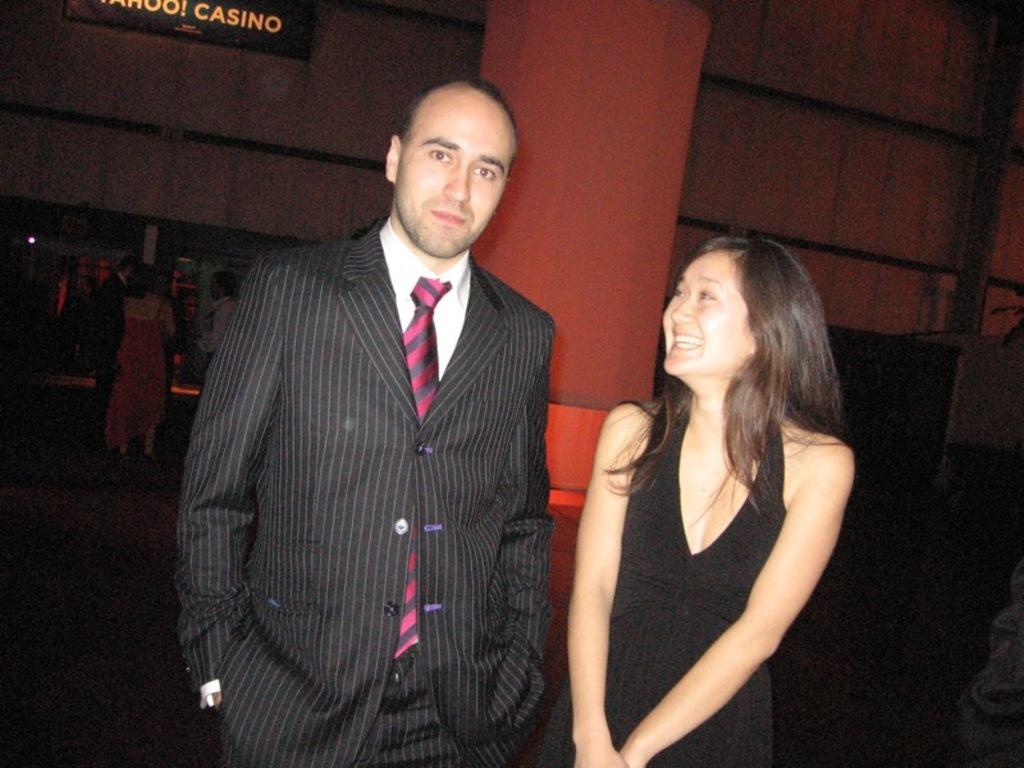Please provide a concise description of this image. In this image I can see two persons visible in front of beam , backside there is the wall , on the left side there are three persons visible on the floor. 